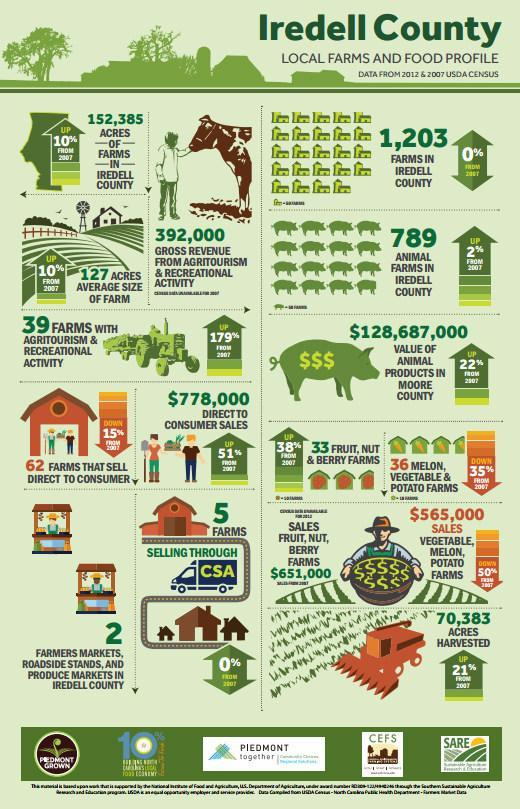The number of which farms decreased from 2007 to 2012?
Answer the question with a short phrase. melon,vegetable,potato farms What saw no change from 2007 to 2012? farms in Iredell county,farms selling through CSA 